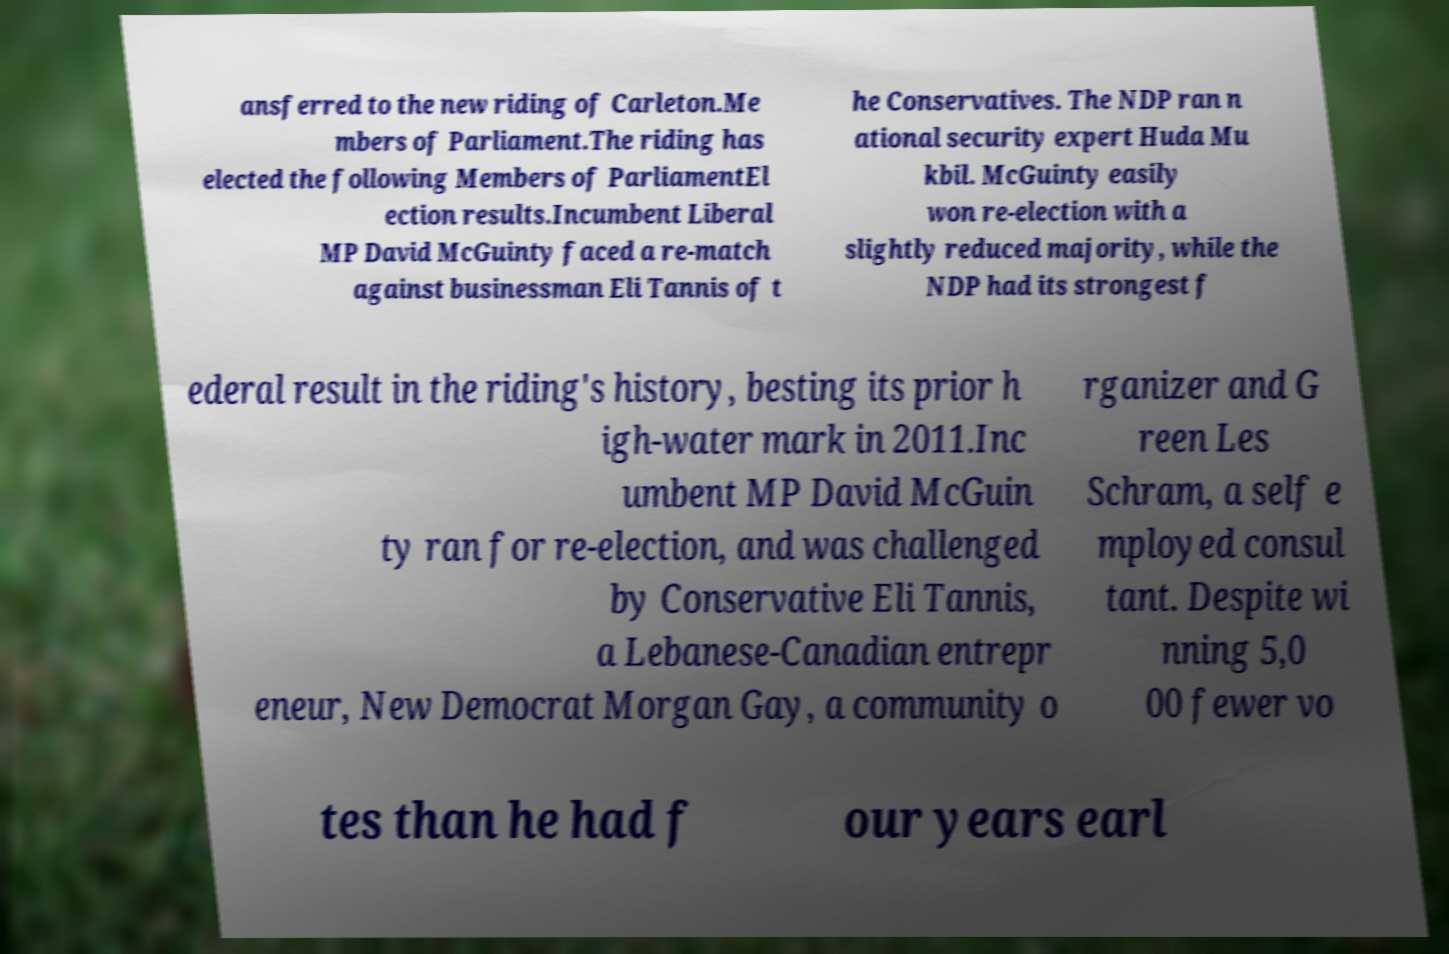For documentation purposes, I need the text within this image transcribed. Could you provide that? ansferred to the new riding of Carleton.Me mbers of Parliament.The riding has elected the following Members of ParliamentEl ection results.Incumbent Liberal MP David McGuinty faced a re-match against businessman Eli Tannis of t he Conservatives. The NDP ran n ational security expert Huda Mu kbil. McGuinty easily won re-election with a slightly reduced majority, while the NDP had its strongest f ederal result in the riding's history, besting its prior h igh-water mark in 2011.Inc umbent MP David McGuin ty ran for re-election, and was challenged by Conservative Eli Tannis, a Lebanese-Canadian entrepr eneur, New Democrat Morgan Gay, a community o rganizer and G reen Les Schram, a self e mployed consul tant. Despite wi nning 5,0 00 fewer vo tes than he had f our years earl 